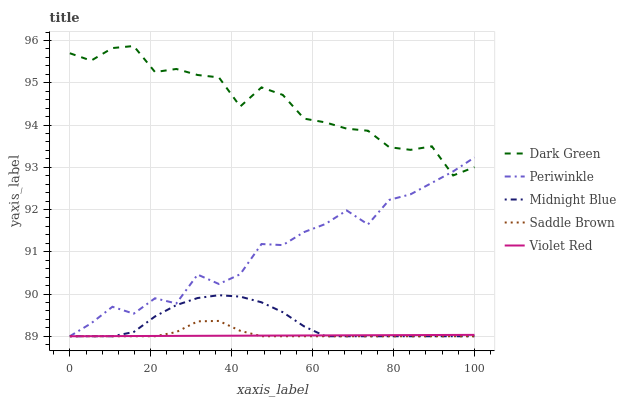Does Violet Red have the minimum area under the curve?
Answer yes or no. Yes. Does Dark Green have the maximum area under the curve?
Answer yes or no. Yes. Does Periwinkle have the minimum area under the curve?
Answer yes or no. No. Does Periwinkle have the maximum area under the curve?
Answer yes or no. No. Is Violet Red the smoothest?
Answer yes or no. Yes. Is Dark Green the roughest?
Answer yes or no. Yes. Is Periwinkle the smoothest?
Answer yes or no. No. Is Periwinkle the roughest?
Answer yes or no. No. Does Saddle Brown have the lowest value?
Answer yes or no. Yes. Does Periwinkle have the lowest value?
Answer yes or no. No. Does Dark Green have the highest value?
Answer yes or no. Yes. Does Periwinkle have the highest value?
Answer yes or no. No. Is Midnight Blue less than Dark Green?
Answer yes or no. Yes. Is Periwinkle greater than Midnight Blue?
Answer yes or no. Yes. Does Periwinkle intersect Dark Green?
Answer yes or no. Yes. Is Periwinkle less than Dark Green?
Answer yes or no. No. Is Periwinkle greater than Dark Green?
Answer yes or no. No. Does Midnight Blue intersect Dark Green?
Answer yes or no. No. 